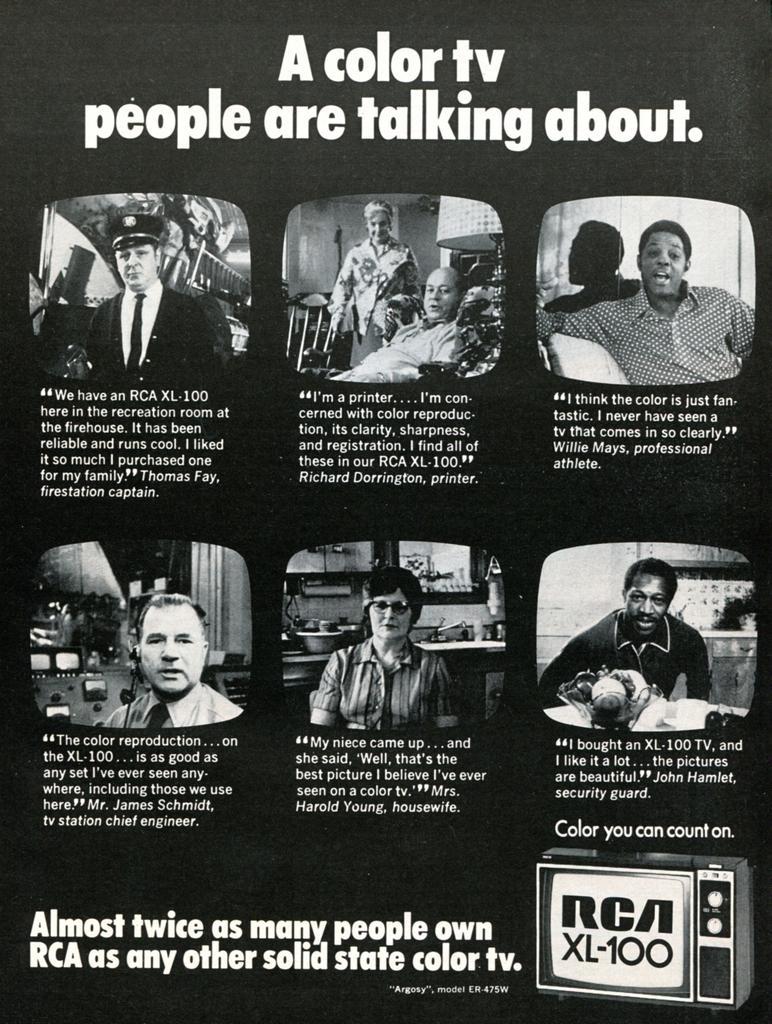Please provide a concise description of this image. In this picture, it seems like a collage poster and text. 